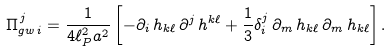<formula> <loc_0><loc_0><loc_500><loc_500>\Pi _ { g w \, i } ^ { \, j } = \frac { 1 } { 4 \ell _ { P } ^ { 2 } a ^ { 2 } } \left [ - \partial _ { i } \, h _ { k \ell } \, \partial ^ { j } \, h ^ { k \ell } + \frac { 1 } { 3 } \delta _ { i } ^ { j } \, \partial _ { m } \, h _ { k \ell } \, \partial _ { m } \, h _ { k \ell } \right ] .</formula> 